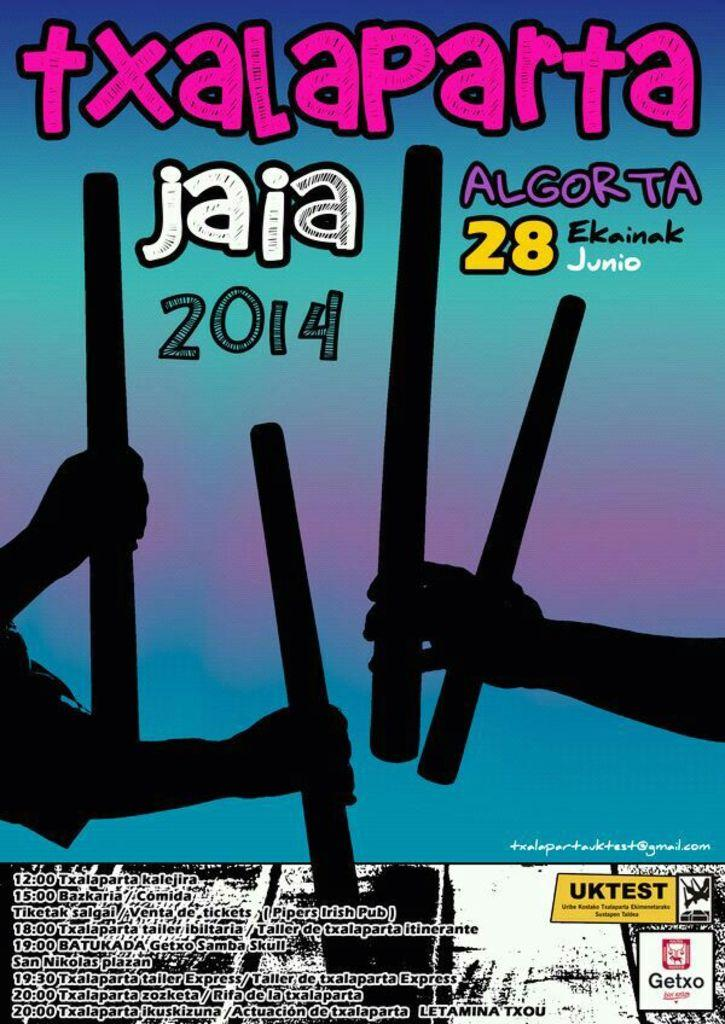<image>
Offer a succinct explanation of the picture presented. A poster picturing shadow-like hands holding sticks advertises Txalaparta Jaia 2014. 